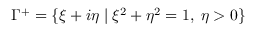Convert formula to latex. <formula><loc_0><loc_0><loc_500><loc_500>\Gamma ^ { + } = \{ \xi + i \eta \, | \, \xi ^ { 2 } + \eta ^ { 2 } = 1 , \, \eta > 0 \}</formula> 